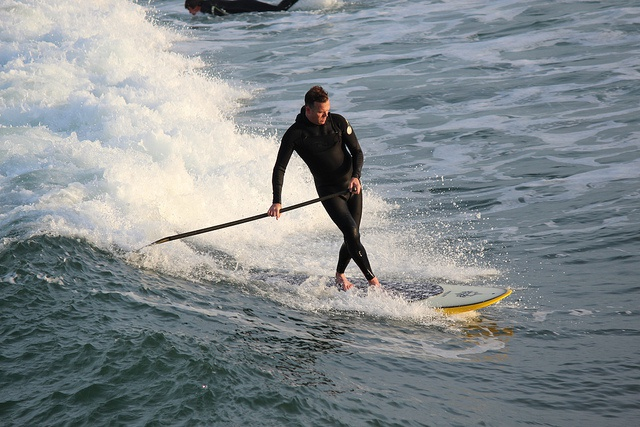Describe the objects in this image and their specific colors. I can see people in darkgray, black, maroon, and gray tones and surfboard in darkgray, gray, tan, and lightgray tones in this image. 